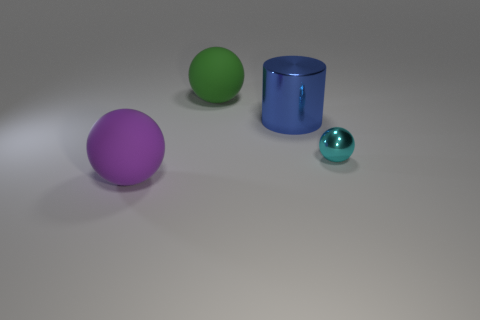Can you describe the shape and color of the objects in the foreground and background? Certainly! In the foreground, there is a large purple sphere and a smaller teal sphere. In the background, there is a green sphere, and next to it sits a blue cylindrical object with a reflective surface. 